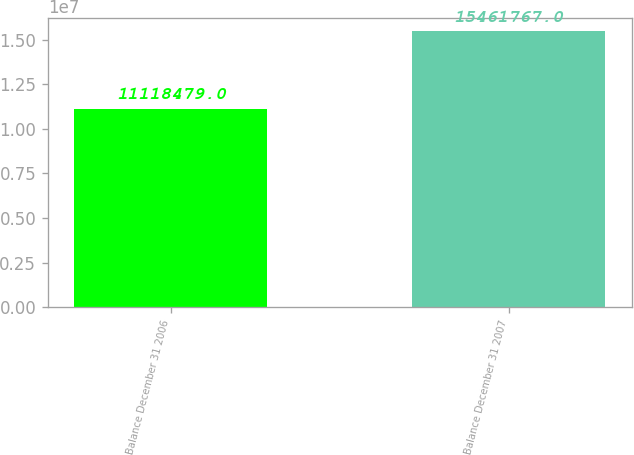Convert chart. <chart><loc_0><loc_0><loc_500><loc_500><bar_chart><fcel>Balance December 31 2006<fcel>Balance December 31 2007<nl><fcel>1.11185e+07<fcel>1.54618e+07<nl></chart> 